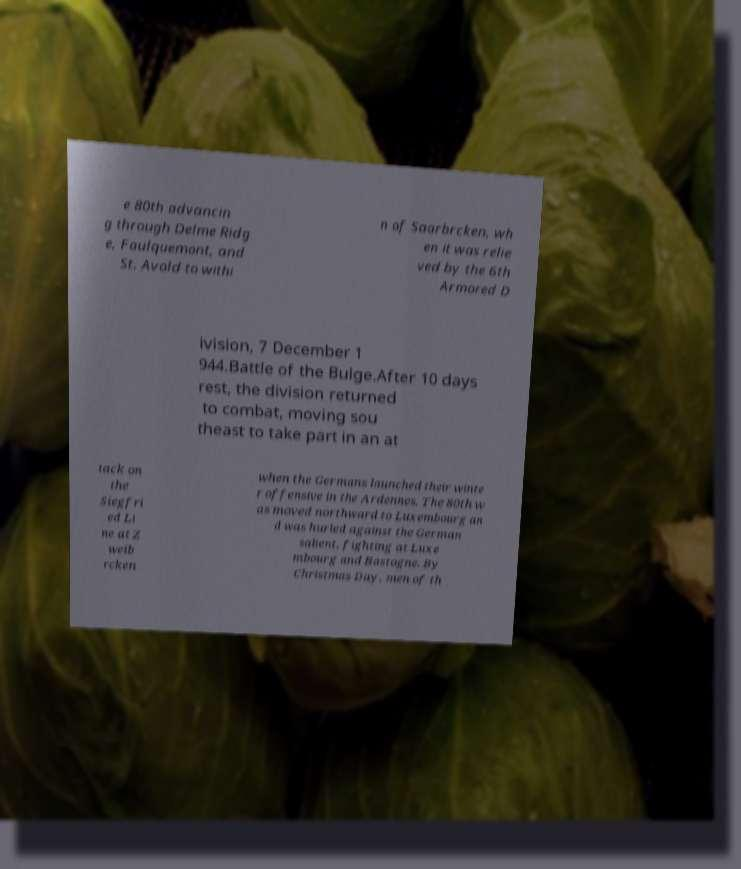Could you assist in decoding the text presented in this image and type it out clearly? e 80th advancin g through Delme Ridg e, Faulquemont, and St. Avold to withi n of Saarbrcken, wh en it was relie ved by the 6th Armored D ivision, 7 December 1 944.Battle of the Bulge.After 10 days rest, the division returned to combat, moving sou theast to take part in an at tack on the Siegfri ed Li ne at Z weib rcken when the Germans launched their winte r offensive in the Ardennes. The 80th w as moved northward to Luxembourg an d was hurled against the German salient, fighting at Luxe mbourg and Bastogne. By Christmas Day, men of th 